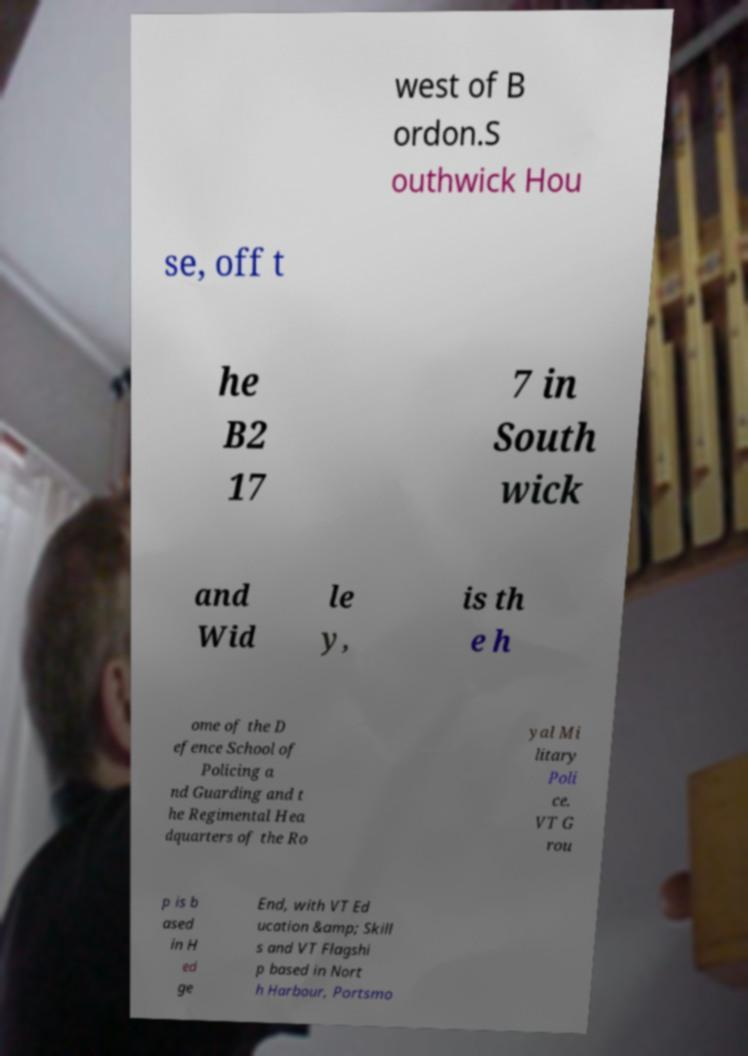For documentation purposes, I need the text within this image transcribed. Could you provide that? west of B ordon.S outhwick Hou se, off t he B2 17 7 in South wick and Wid le y, is th e h ome of the D efence School of Policing a nd Guarding and t he Regimental Hea dquarters of the Ro yal Mi litary Poli ce. VT G rou p is b ased in H ed ge End, with VT Ed ucation &amp; Skill s and VT Flagshi p based in Nort h Harbour, Portsmo 